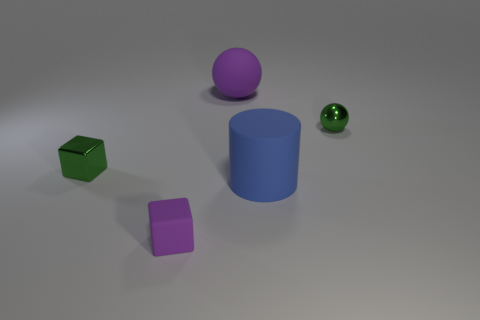What is the color of the rubber block?
Offer a terse response. Purple. There is a tiny green thing to the left of the blue rubber cylinder; how many small green spheres are to the left of it?
Make the answer very short. 0. There is a matte cube; is it the same size as the shiny object that is left of the purple sphere?
Provide a short and direct response. Yes. Does the matte sphere have the same size as the blue matte cylinder?
Provide a succinct answer. Yes. Are there any purple matte blocks that have the same size as the matte cylinder?
Offer a very short reply. No. What is the material of the big object in front of the large purple object?
Offer a very short reply. Rubber. What color is the big thing that is the same material as the large ball?
Keep it short and to the point. Blue. How many matte things are either purple balls or tiny gray things?
Make the answer very short. 1. The green thing that is the same size as the green metal block is what shape?
Provide a short and direct response. Sphere. How many objects are matte objects that are on the right side of the large purple ball or green metallic things that are in front of the metal sphere?
Make the answer very short. 2. 